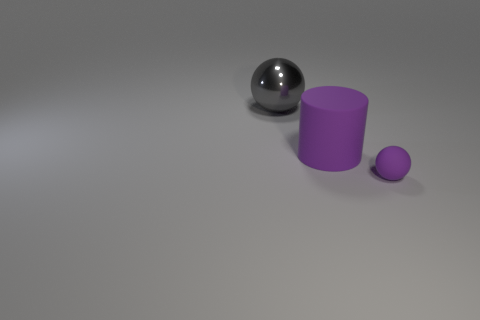There is another thing that is the same color as the small matte object; what material is it?
Your answer should be compact. Rubber. Is there any other thing that is the same shape as the small purple rubber object?
Your answer should be very brief. Yes. There is a purple object to the left of the small ball; what is it made of?
Keep it short and to the point. Rubber. Is there any other thing that is the same size as the gray metal ball?
Your response must be concise. Yes. There is a tiny purple matte object; are there any tiny purple spheres to the left of it?
Provide a short and direct response. No. What shape is the tiny object?
Your response must be concise. Sphere. What number of objects are either things in front of the big metal thing or purple objects?
Ensure brevity in your answer.  2. What number of other objects are the same color as the tiny ball?
Your answer should be very brief. 1. There is a large cylinder; does it have the same color as the ball that is on the right side of the big shiny object?
Offer a very short reply. Yes. What color is the other thing that is the same shape as the big gray metal thing?
Ensure brevity in your answer.  Purple. 